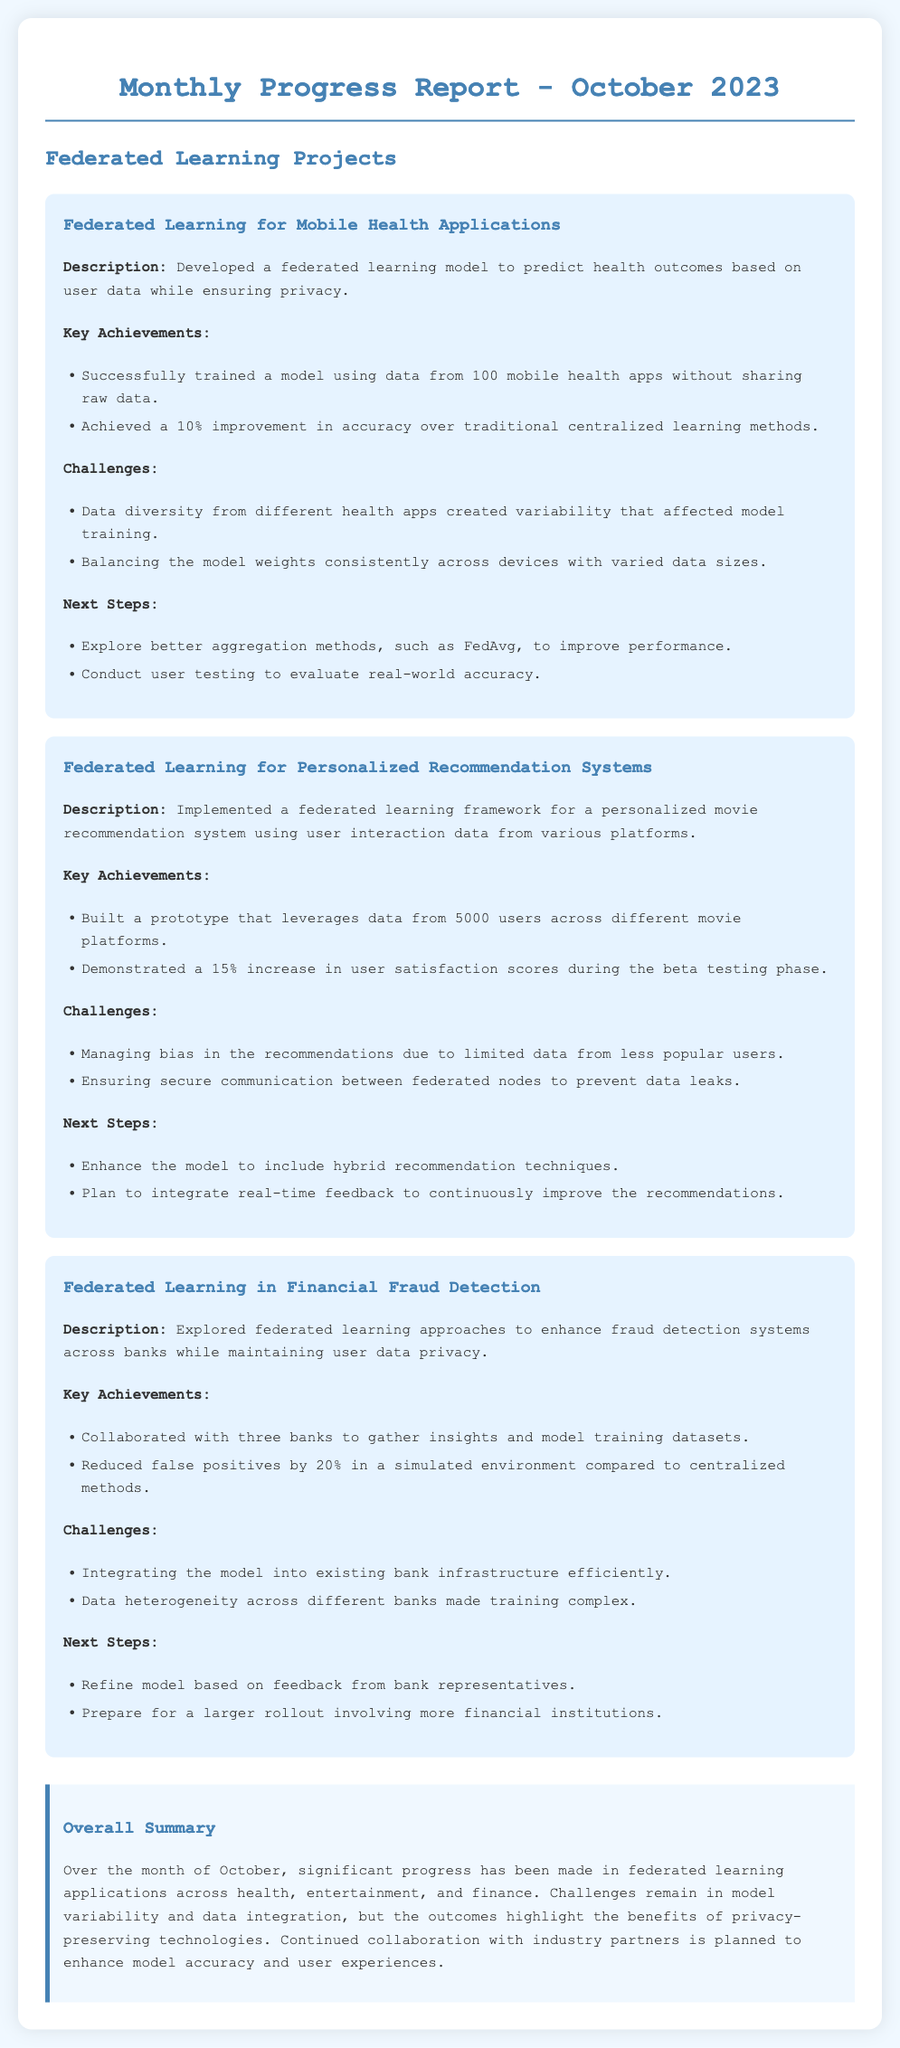What is the title of the report? The title of the report is mentioned at the beginning of the document, indicating what the report is about.
Answer: Monthly Progress Report - October 2023 How many mobile health apps were used in the first project? The first project specifically mentions the number of mobile health apps involved in the federated learning model.
Answer: 100 What percentage improvement in accuracy was achieved in personalized recommendation systems? The second project highlights the percentage of user satisfaction increase achieved during the beta testing phase.
Answer: 15% What is one of the challenges faced in financial fraud detection? The challenges section for the financial fraud detection project lists specific issues encountered during implementation.
Answer: Data heterogeneity What is the next step for the mobile health applications project? The next steps listed in the projects indicate what future actions are planned for ongoing development.
Answer: Explore better aggregation methods How many users' data was leveraged in the recommendation system? The document specifies the user count that contributed to the prototype in the second project, indicating its scale.
Answer: 5000 What was the percentage reduction in false positives for the financial fraud detection project? The key achievements section mentions the reduction rate compared to centralized methods in this project.
Answer: 20% Who collaborated with the financial fraud detection project? The document identifies the type of organizations involved in gathering insights and datasets for model training.
Answer: three banks What technology is being aimed to enhance through continuous collaboration? The overall summary in the document mentions the main goal of future collaborations across the projects.
Answer: model accuracy 